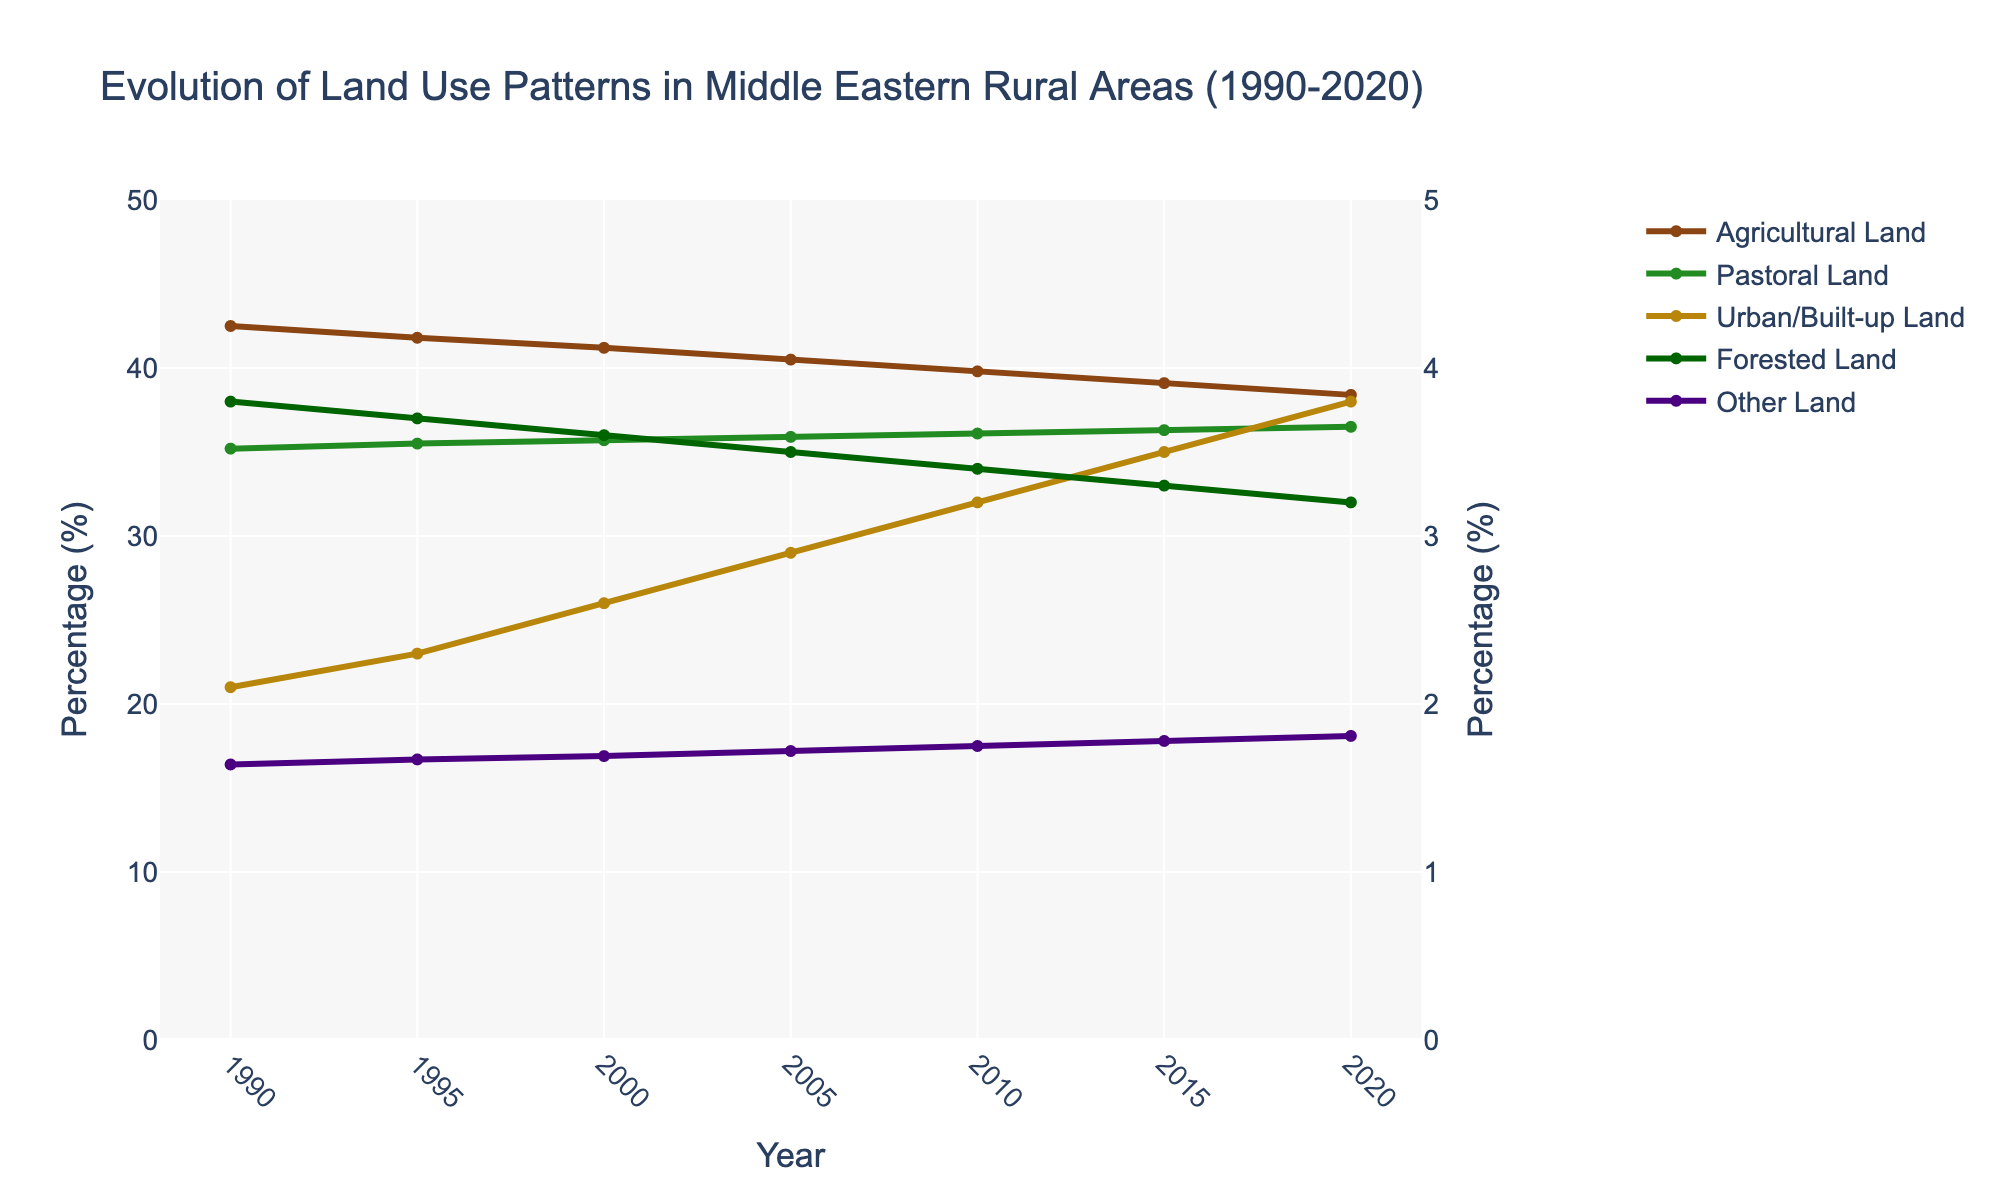What is the overall trend in Agricultural Land from 1990 to 2020? The percentage of Agricultural Land decreases steadily from 42.5% in 1990 to 38.4% in 2020. This trend can be identified by observing the downward slope of the line representing Agricultural Land from left to right on the chart.
Answer: Steady decrease Which land type has seen the largest increase in percentage between 1990 and 2020? To find the largest increase, we compare the percentages from 1990 to 2020 for all land types. Agricultural Land decreases from 42.5% to 38.4% (a decrease of 4.1%), Pastoral Land increases from 35.2% to 36.5% (an increase of 1.3%), Urban/Built-up Land increases from 2.1% to 3.8% (an increase of 1.7%), Forested Land decreases from 3.8% to 3.2% (a decrease of 0.6%), and Other Land increases from 16.4% to 18.1% (an increase of 1.7%).
Answer: Urban/Built-up Land and Other Land How does the trend in Urban/Built-up Land compare with Forested Land from 1990 to 2020? To compare trends, we observe the line for Urban/Built-up Land and Forested Land over time. Urban/Built-up Land shows an increasing trend, rising from 2.1% to 3.8%. Forested Land, on the other hand, shows a decreasing trend, falling from 3.8% to 3.2%.
Answer: Urban/Built-up Land increases, Forested Land decreases By how much did Pastoral Land change from 1990 to 2020? We look at the percentage of Pastoral Land in 1990 and 2020. In 1990, it was 35.2%, and in 2020, it was 36.5%. The change in Pastoral Land is 36.5% - 35.2% = 1.3%.
Answer: Increased by 1.3% What is the sum of the percentages of Agricultural Land and Urban/Built-up Land in 2020? To find the sum of the percentages of Agricultural Land and Urban/Built-up Land in 2020, we add the respective values: 38.4% (Agricultural Land) + 3.8% (Urban/Built-up Land) = 42.2%.
Answer: 42.2% Are there any land types that remained constant in their percentage over the years? Reviewing the plot for each land type, we observe that the percentages change for each land type over the years, although some changes are more subtle. No land type remains completely constant from 1990 to 2020.
Answer: No Which year shows the highest percentage of Forested Land? Looking at the line for Forested Land, the highest percentage value can be identified at the peak point on the graph. It was highest in 1990 at 3.8%.
Answer: 1990 What is the difference in percentage between Agricultural Land and Urban/Built-up Land in 2015? To find the difference, subtract the percentage of Urban/Built-up Land from Agricultural Land in 2015. The values are 39.1% (Agricultural Land) and 3.5% (Urban/Built-up Land), so the difference is 39.1% - 3.5% = 35.6%.
Answer: 35.6% In what period did Other Land experience the most significant increase? By examining the Other Land line graph, we identify the period with the steepest increase. The visual slope is steepest between 2015 (17.8%) and 2020 (18.1%), indicating the most significant increase.
Answer: Between 2015 and 2020 